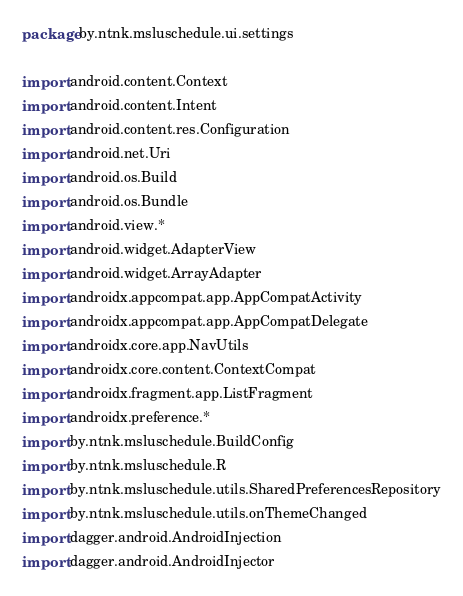Convert code to text. <code><loc_0><loc_0><loc_500><loc_500><_Kotlin_>package by.ntnk.msluschedule.ui.settings

import android.content.Context
import android.content.Intent
import android.content.res.Configuration
import android.net.Uri
import android.os.Build
import android.os.Bundle
import android.view.*
import android.widget.AdapterView
import android.widget.ArrayAdapter
import androidx.appcompat.app.AppCompatActivity
import androidx.appcompat.app.AppCompatDelegate
import androidx.core.app.NavUtils
import androidx.core.content.ContextCompat
import androidx.fragment.app.ListFragment
import androidx.preference.*
import by.ntnk.msluschedule.BuildConfig
import by.ntnk.msluschedule.R
import by.ntnk.msluschedule.utils.SharedPreferencesRepository
import by.ntnk.msluschedule.utils.onThemeChanged
import dagger.android.AndroidInjection
import dagger.android.AndroidInjector</code> 